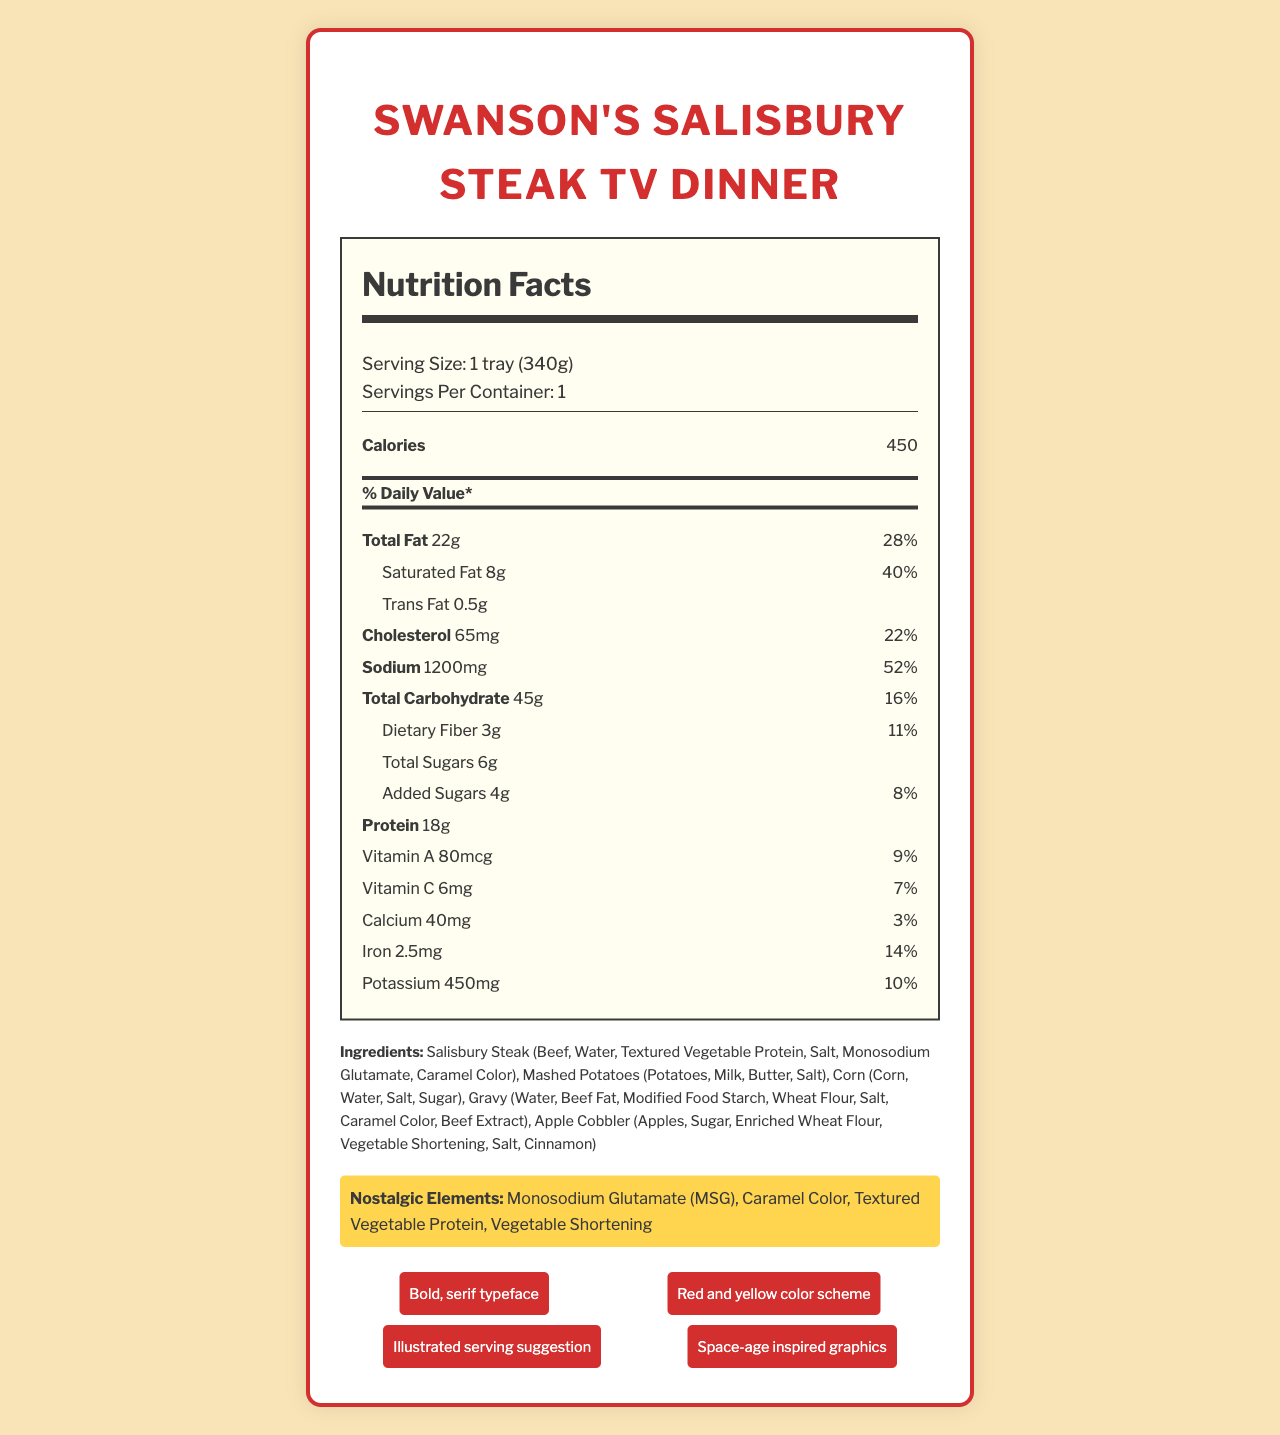what is the serving size of Swanson's Salisbury Steak TV Dinner? The document explicitly states the serving size as "1 tray (340g)" under the nutrition facts section.
Answer: 1 tray (340g) how many grams of total fat does the TV dinner contain? The nutrition facts section lists "Total Fat" as 22g.
Answer: 22g what is the percentage daily value of saturated fat? The document lists the daily value percentage of saturated fat as 40% under the nutrition facts section.
Answer: 40% does the TV dinner contain any trans fat? The document lists "Trans Fat" as 0.5g, indicating its presence.
Answer: Yes what are the nostalgic elements mentioned in the document? The ingredients section highlights nostalgic elements like Monosodium Glutamate (MSG), Caramel Color, Textured Vegetable Protein, and Vegetable Shortening specifically.
Answer: Monosodium Glutamate (MSG), Caramel Color, Textured Vegetable Protein, Vegetable Shortening what is the total amount of added sugars in the TV dinner? The nutrition facts section specifies that the total amount of added sugars is 4g.
Answer: 4g how much potassium is in the TV dinner in milligrams? The nutrition facts section lists "Potassium" as 450mg.
Answer: 450mg how long should the TV dinner be cooked in the oven? The cooking instructions state that the TV dinner should be cooked for 25-30 minutes.
Answer: 25-30 minutes which nutrient has the highest daily value percentage?  
  A. Sodium  
  B. Saturated Fat  
  C. Cholesterol  
  D. Total Carbohydrate Sodium (52%) has the highest daily value percentage among all listed nutrients in the nutrition facts section.
Answer: A how many grams of protein does the TV dinner contain?  
  1. 10g  
  2. 18g  
  3. 20g  
  4. 25g The nutrition facts section lists "Protein" as 18g.
Answer: 2 Is the apple cobbler included in the TV dinner? The ingredients list includes "Apple Cobbler," indicating its presence in the TV dinner.
Answer: Yes summarize the main idea of the document. The document provides an overview of nutrient content, ingredients list, nostalgic food elements, and packaging design, emphasizing its 1950s retro aesthetic.
Answer: The document presents the nutrition facts, ingredients, nostalgic elements, and retro design elements for Swanson's Salisbury Steak TV Dinner. It highlights preparation instructions and provides a nostalgic nod to the 1950s with its ingredients and design. does the document provide information about the price of the TV dinner? The document does not contain any information regarding the price of the TV dinner. It mainly focuses on nutritional info, ingredients, and design elements.
Answer: No 